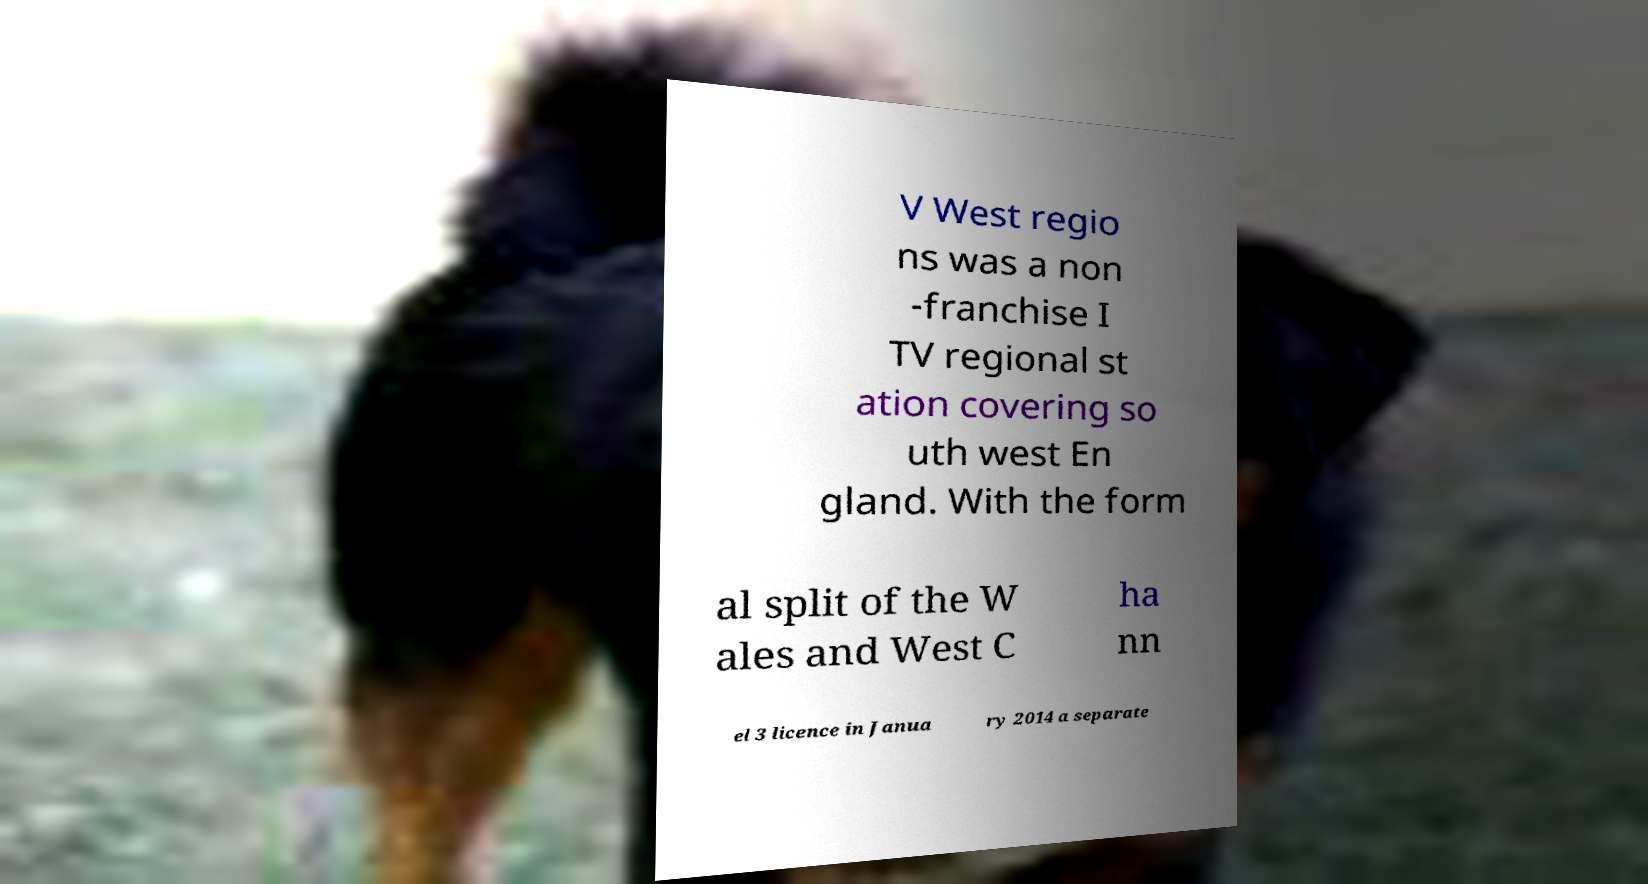Can you accurately transcribe the text from the provided image for me? V West regio ns was a non -franchise I TV regional st ation covering so uth west En gland. With the form al split of the W ales and West C ha nn el 3 licence in Janua ry 2014 a separate 